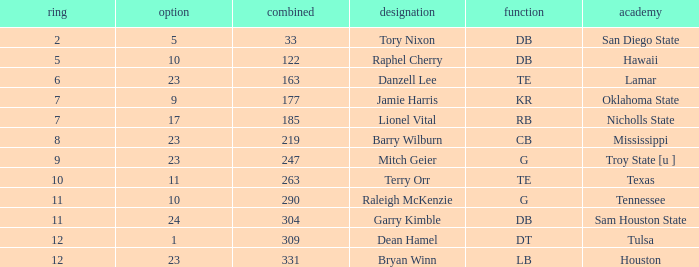Which Round is the highest one that has a Pick smaller than 10, and a Name of tory nixon? 2.0. Help me parse the entirety of this table. {'header': ['ring', 'option', 'combined', 'designation', 'function', 'academy'], 'rows': [['2', '5', '33', 'Tory Nixon', 'DB', 'San Diego State'], ['5', '10', '122', 'Raphel Cherry', 'DB', 'Hawaii'], ['6', '23', '163', 'Danzell Lee', 'TE', 'Lamar'], ['7', '9', '177', 'Jamie Harris', 'KR', 'Oklahoma State'], ['7', '17', '185', 'Lionel Vital', 'RB', 'Nicholls State'], ['8', '23', '219', 'Barry Wilburn', 'CB', 'Mississippi'], ['9', '23', '247', 'Mitch Geier', 'G', 'Troy State [u ]'], ['10', '11', '263', 'Terry Orr', 'TE', 'Texas'], ['11', '10', '290', 'Raleigh McKenzie', 'G', 'Tennessee'], ['11', '24', '304', 'Garry Kimble', 'DB', 'Sam Houston State'], ['12', '1', '309', 'Dean Hamel', 'DT', 'Tulsa'], ['12', '23', '331', 'Bryan Winn', 'LB', 'Houston']]} 